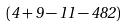<formula> <loc_0><loc_0><loc_500><loc_500>( 4 + 9 - 1 1 - 4 8 2 )</formula> 